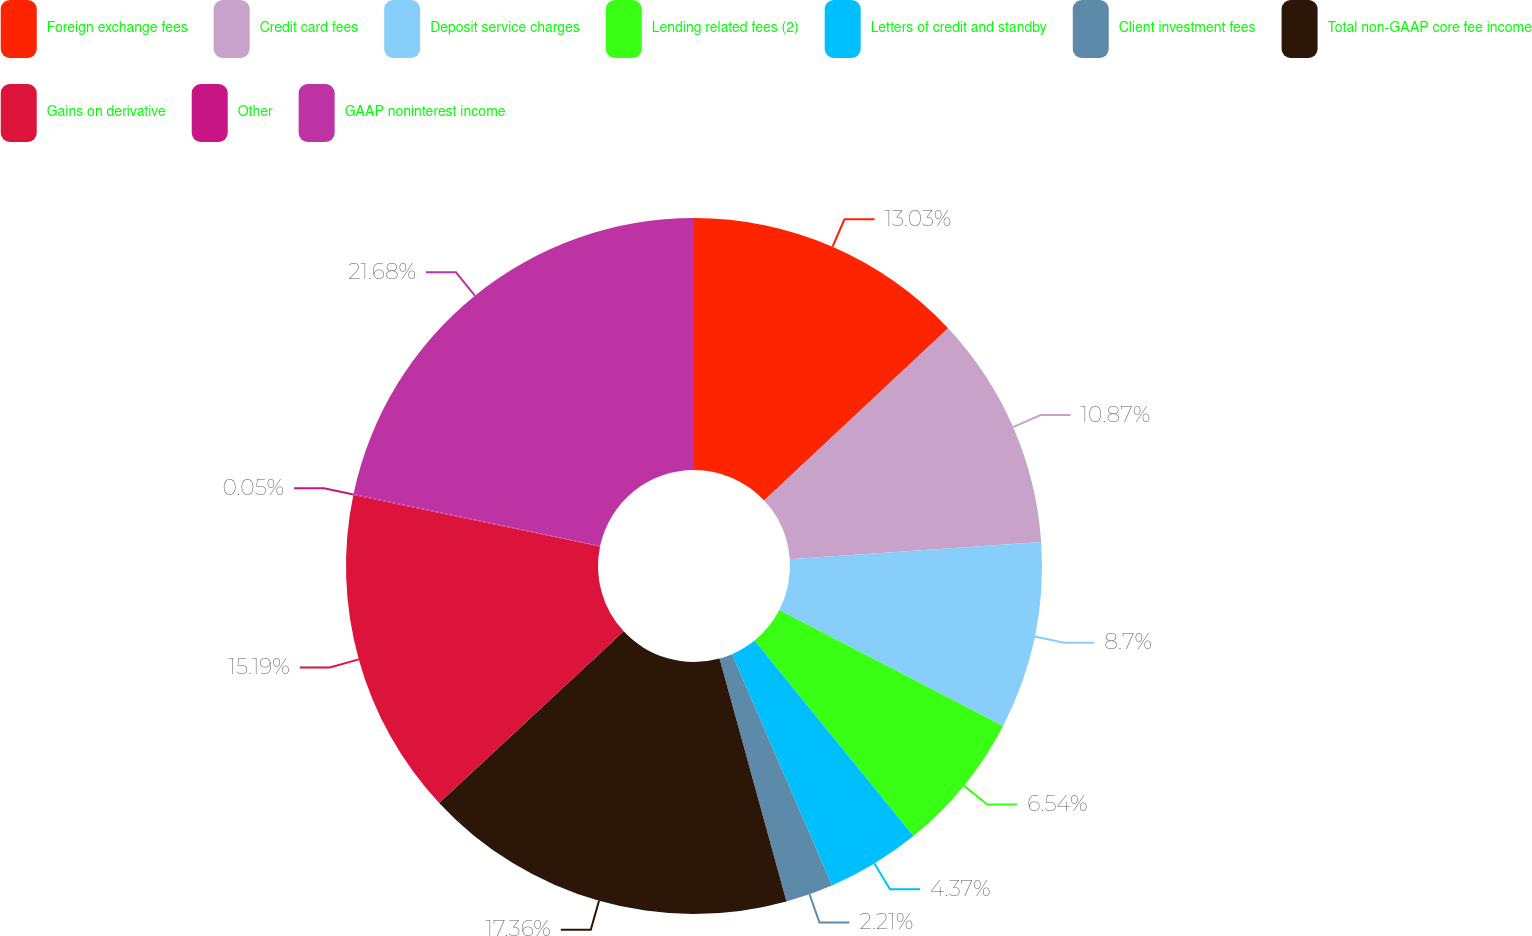Convert chart to OTSL. <chart><loc_0><loc_0><loc_500><loc_500><pie_chart><fcel>Foreign exchange fees<fcel>Credit card fees<fcel>Deposit service charges<fcel>Lending related fees (2)<fcel>Letters of credit and standby<fcel>Client investment fees<fcel>Total non-GAAP core fee income<fcel>Gains on derivative<fcel>Other<fcel>GAAP noninterest income<nl><fcel>13.03%<fcel>10.87%<fcel>8.7%<fcel>6.54%<fcel>4.37%<fcel>2.21%<fcel>17.36%<fcel>15.19%<fcel>0.05%<fcel>21.68%<nl></chart> 